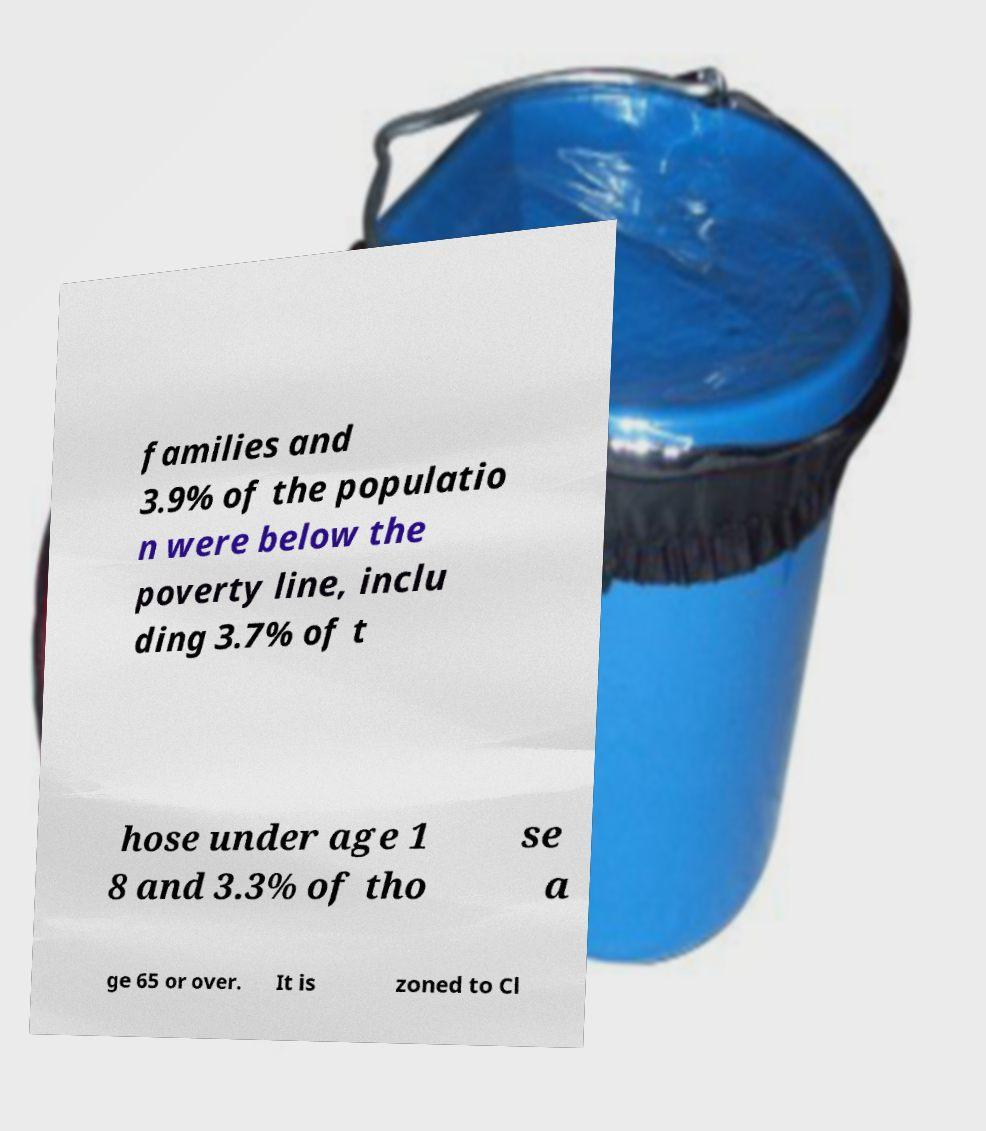There's text embedded in this image that I need extracted. Can you transcribe it verbatim? families and 3.9% of the populatio n were below the poverty line, inclu ding 3.7% of t hose under age 1 8 and 3.3% of tho se a ge 65 or over. It is zoned to Cl 